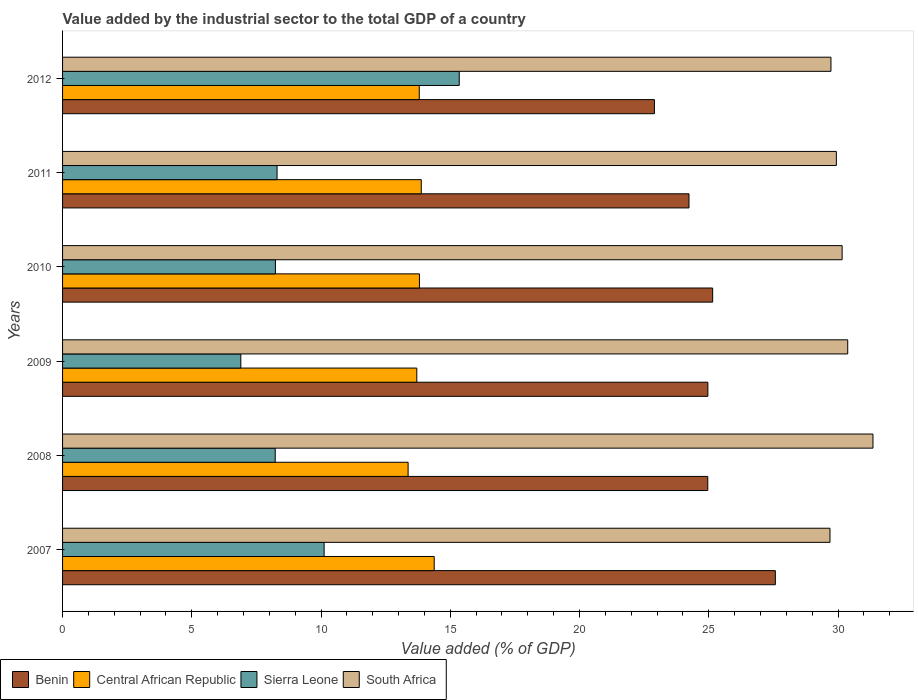How many groups of bars are there?
Make the answer very short. 6. Are the number of bars per tick equal to the number of legend labels?
Keep it short and to the point. Yes. Are the number of bars on each tick of the Y-axis equal?
Give a very brief answer. Yes. What is the label of the 4th group of bars from the top?
Provide a short and direct response. 2009. What is the value added by the industrial sector to the total GDP in Benin in 2007?
Provide a succinct answer. 27.58. Across all years, what is the maximum value added by the industrial sector to the total GDP in South Africa?
Offer a very short reply. 31.35. Across all years, what is the minimum value added by the industrial sector to the total GDP in Sierra Leone?
Your answer should be compact. 6.9. In which year was the value added by the industrial sector to the total GDP in South Africa maximum?
Provide a succinct answer. 2008. In which year was the value added by the industrial sector to the total GDP in Benin minimum?
Ensure brevity in your answer.  2012. What is the total value added by the industrial sector to the total GDP in Sierra Leone in the graph?
Your response must be concise. 57.12. What is the difference between the value added by the industrial sector to the total GDP in Central African Republic in 2007 and that in 2010?
Keep it short and to the point. 0.57. What is the difference between the value added by the industrial sector to the total GDP in Sierra Leone in 2010 and the value added by the industrial sector to the total GDP in Central African Republic in 2012?
Give a very brief answer. -5.57. What is the average value added by the industrial sector to the total GDP in Central African Republic per year?
Your answer should be very brief. 13.82. In the year 2007, what is the difference between the value added by the industrial sector to the total GDP in Benin and value added by the industrial sector to the total GDP in Sierra Leone?
Ensure brevity in your answer.  17.46. In how many years, is the value added by the industrial sector to the total GDP in Sierra Leone greater than 29 %?
Offer a terse response. 0. What is the ratio of the value added by the industrial sector to the total GDP in Benin in 2010 to that in 2011?
Give a very brief answer. 1.04. Is the difference between the value added by the industrial sector to the total GDP in Benin in 2007 and 2012 greater than the difference between the value added by the industrial sector to the total GDP in Sierra Leone in 2007 and 2012?
Provide a succinct answer. Yes. What is the difference between the highest and the second highest value added by the industrial sector to the total GDP in Benin?
Your response must be concise. 2.43. What is the difference between the highest and the lowest value added by the industrial sector to the total GDP in Sierra Leone?
Your answer should be compact. 8.45. Is it the case that in every year, the sum of the value added by the industrial sector to the total GDP in Benin and value added by the industrial sector to the total GDP in Central African Republic is greater than the sum of value added by the industrial sector to the total GDP in South Africa and value added by the industrial sector to the total GDP in Sierra Leone?
Provide a short and direct response. Yes. What does the 4th bar from the top in 2012 represents?
Your answer should be very brief. Benin. What does the 1st bar from the bottom in 2007 represents?
Your response must be concise. Benin. Is it the case that in every year, the sum of the value added by the industrial sector to the total GDP in Sierra Leone and value added by the industrial sector to the total GDP in Central African Republic is greater than the value added by the industrial sector to the total GDP in South Africa?
Provide a succinct answer. No. Are all the bars in the graph horizontal?
Keep it short and to the point. Yes. What is the difference between two consecutive major ticks on the X-axis?
Your answer should be compact. 5. Are the values on the major ticks of X-axis written in scientific E-notation?
Make the answer very short. No. How many legend labels are there?
Provide a short and direct response. 4. What is the title of the graph?
Your response must be concise. Value added by the industrial sector to the total GDP of a country. Does "China" appear as one of the legend labels in the graph?
Give a very brief answer. No. What is the label or title of the X-axis?
Offer a terse response. Value added (% of GDP). What is the Value added (% of GDP) in Benin in 2007?
Make the answer very short. 27.58. What is the Value added (% of GDP) in Central African Republic in 2007?
Offer a terse response. 14.38. What is the Value added (% of GDP) in Sierra Leone in 2007?
Your response must be concise. 10.12. What is the Value added (% of GDP) in South Africa in 2007?
Keep it short and to the point. 29.69. What is the Value added (% of GDP) in Benin in 2008?
Your response must be concise. 24.96. What is the Value added (% of GDP) of Central African Republic in 2008?
Offer a very short reply. 13.37. What is the Value added (% of GDP) in Sierra Leone in 2008?
Make the answer very short. 8.23. What is the Value added (% of GDP) of South Africa in 2008?
Provide a short and direct response. 31.35. What is the Value added (% of GDP) in Benin in 2009?
Ensure brevity in your answer.  24.97. What is the Value added (% of GDP) of Central African Republic in 2009?
Your response must be concise. 13.7. What is the Value added (% of GDP) of Sierra Leone in 2009?
Give a very brief answer. 6.9. What is the Value added (% of GDP) of South Africa in 2009?
Provide a succinct answer. 30.38. What is the Value added (% of GDP) in Benin in 2010?
Offer a very short reply. 25.15. What is the Value added (% of GDP) of Central African Republic in 2010?
Your answer should be very brief. 13.81. What is the Value added (% of GDP) in Sierra Leone in 2010?
Make the answer very short. 8.23. What is the Value added (% of GDP) in South Africa in 2010?
Provide a short and direct response. 30.16. What is the Value added (% of GDP) in Benin in 2011?
Your answer should be very brief. 24.24. What is the Value added (% of GDP) of Central African Republic in 2011?
Keep it short and to the point. 13.88. What is the Value added (% of GDP) of Sierra Leone in 2011?
Give a very brief answer. 8.3. What is the Value added (% of GDP) in South Africa in 2011?
Make the answer very short. 29.94. What is the Value added (% of GDP) in Benin in 2012?
Provide a short and direct response. 22.9. What is the Value added (% of GDP) in Central African Republic in 2012?
Your answer should be compact. 13.8. What is the Value added (% of GDP) of Sierra Leone in 2012?
Your answer should be very brief. 15.35. What is the Value added (% of GDP) of South Africa in 2012?
Your answer should be compact. 29.73. Across all years, what is the maximum Value added (% of GDP) in Benin?
Provide a short and direct response. 27.58. Across all years, what is the maximum Value added (% of GDP) of Central African Republic?
Provide a succinct answer. 14.38. Across all years, what is the maximum Value added (% of GDP) of Sierra Leone?
Your answer should be compact. 15.35. Across all years, what is the maximum Value added (% of GDP) in South Africa?
Give a very brief answer. 31.35. Across all years, what is the minimum Value added (% of GDP) in Benin?
Offer a terse response. 22.9. Across all years, what is the minimum Value added (% of GDP) in Central African Republic?
Offer a terse response. 13.37. Across all years, what is the minimum Value added (% of GDP) of Sierra Leone?
Your answer should be very brief. 6.9. Across all years, what is the minimum Value added (% of GDP) of South Africa?
Provide a succinct answer. 29.69. What is the total Value added (% of GDP) of Benin in the graph?
Offer a very short reply. 149.79. What is the total Value added (% of GDP) of Central African Republic in the graph?
Offer a terse response. 82.93. What is the total Value added (% of GDP) of Sierra Leone in the graph?
Keep it short and to the point. 57.12. What is the total Value added (% of GDP) of South Africa in the graph?
Offer a very short reply. 181.24. What is the difference between the Value added (% of GDP) in Benin in 2007 and that in 2008?
Provide a succinct answer. 2.61. What is the difference between the Value added (% of GDP) in Central African Republic in 2007 and that in 2008?
Keep it short and to the point. 1.01. What is the difference between the Value added (% of GDP) of Sierra Leone in 2007 and that in 2008?
Give a very brief answer. 1.89. What is the difference between the Value added (% of GDP) in South Africa in 2007 and that in 2008?
Your answer should be very brief. -1.66. What is the difference between the Value added (% of GDP) of Benin in 2007 and that in 2009?
Your response must be concise. 2.61. What is the difference between the Value added (% of GDP) of Central African Republic in 2007 and that in 2009?
Ensure brevity in your answer.  0.67. What is the difference between the Value added (% of GDP) of Sierra Leone in 2007 and that in 2009?
Offer a very short reply. 3.22. What is the difference between the Value added (% of GDP) in South Africa in 2007 and that in 2009?
Provide a succinct answer. -0.69. What is the difference between the Value added (% of GDP) of Benin in 2007 and that in 2010?
Your answer should be compact. 2.43. What is the difference between the Value added (% of GDP) in Central African Republic in 2007 and that in 2010?
Make the answer very short. 0.57. What is the difference between the Value added (% of GDP) of Sierra Leone in 2007 and that in 2010?
Your response must be concise. 1.88. What is the difference between the Value added (% of GDP) of South Africa in 2007 and that in 2010?
Ensure brevity in your answer.  -0.47. What is the difference between the Value added (% of GDP) of Benin in 2007 and that in 2011?
Offer a terse response. 3.34. What is the difference between the Value added (% of GDP) in Central African Republic in 2007 and that in 2011?
Ensure brevity in your answer.  0.5. What is the difference between the Value added (% of GDP) of Sierra Leone in 2007 and that in 2011?
Give a very brief answer. 1.82. What is the difference between the Value added (% of GDP) of South Africa in 2007 and that in 2011?
Your answer should be very brief. -0.25. What is the difference between the Value added (% of GDP) of Benin in 2007 and that in 2012?
Keep it short and to the point. 4.68. What is the difference between the Value added (% of GDP) of Central African Republic in 2007 and that in 2012?
Keep it short and to the point. 0.58. What is the difference between the Value added (% of GDP) of Sierra Leone in 2007 and that in 2012?
Ensure brevity in your answer.  -5.23. What is the difference between the Value added (% of GDP) of South Africa in 2007 and that in 2012?
Keep it short and to the point. -0.04. What is the difference between the Value added (% of GDP) in Benin in 2008 and that in 2009?
Your answer should be very brief. -0. What is the difference between the Value added (% of GDP) in Central African Republic in 2008 and that in 2009?
Your answer should be very brief. -0.34. What is the difference between the Value added (% of GDP) of Sierra Leone in 2008 and that in 2009?
Make the answer very short. 1.33. What is the difference between the Value added (% of GDP) of South Africa in 2008 and that in 2009?
Keep it short and to the point. 0.98. What is the difference between the Value added (% of GDP) of Benin in 2008 and that in 2010?
Provide a succinct answer. -0.19. What is the difference between the Value added (% of GDP) of Central African Republic in 2008 and that in 2010?
Provide a succinct answer. -0.44. What is the difference between the Value added (% of GDP) in Sierra Leone in 2008 and that in 2010?
Your response must be concise. -0.01. What is the difference between the Value added (% of GDP) in South Africa in 2008 and that in 2010?
Give a very brief answer. 1.19. What is the difference between the Value added (% of GDP) of Benin in 2008 and that in 2011?
Provide a short and direct response. 0.73. What is the difference between the Value added (% of GDP) in Central African Republic in 2008 and that in 2011?
Your answer should be very brief. -0.51. What is the difference between the Value added (% of GDP) in Sierra Leone in 2008 and that in 2011?
Make the answer very short. -0.07. What is the difference between the Value added (% of GDP) in South Africa in 2008 and that in 2011?
Your answer should be very brief. 1.42. What is the difference between the Value added (% of GDP) of Benin in 2008 and that in 2012?
Your response must be concise. 2.06. What is the difference between the Value added (% of GDP) in Central African Republic in 2008 and that in 2012?
Offer a terse response. -0.43. What is the difference between the Value added (% of GDP) of Sierra Leone in 2008 and that in 2012?
Give a very brief answer. -7.12. What is the difference between the Value added (% of GDP) in South Africa in 2008 and that in 2012?
Your response must be concise. 1.63. What is the difference between the Value added (% of GDP) of Benin in 2009 and that in 2010?
Offer a terse response. -0.19. What is the difference between the Value added (% of GDP) of Central African Republic in 2009 and that in 2010?
Your response must be concise. -0.1. What is the difference between the Value added (% of GDP) in Sierra Leone in 2009 and that in 2010?
Make the answer very short. -1.34. What is the difference between the Value added (% of GDP) of South Africa in 2009 and that in 2010?
Make the answer very short. 0.22. What is the difference between the Value added (% of GDP) in Benin in 2009 and that in 2011?
Your answer should be compact. 0.73. What is the difference between the Value added (% of GDP) of Central African Republic in 2009 and that in 2011?
Provide a short and direct response. -0.17. What is the difference between the Value added (% of GDP) in Sierra Leone in 2009 and that in 2011?
Give a very brief answer. -1.4. What is the difference between the Value added (% of GDP) of South Africa in 2009 and that in 2011?
Your response must be concise. 0.44. What is the difference between the Value added (% of GDP) of Benin in 2009 and that in 2012?
Offer a very short reply. 2.07. What is the difference between the Value added (% of GDP) in Central African Republic in 2009 and that in 2012?
Keep it short and to the point. -0.1. What is the difference between the Value added (% of GDP) of Sierra Leone in 2009 and that in 2012?
Provide a succinct answer. -8.45. What is the difference between the Value added (% of GDP) of South Africa in 2009 and that in 2012?
Ensure brevity in your answer.  0.65. What is the difference between the Value added (% of GDP) of Benin in 2010 and that in 2011?
Make the answer very short. 0.92. What is the difference between the Value added (% of GDP) of Central African Republic in 2010 and that in 2011?
Give a very brief answer. -0.07. What is the difference between the Value added (% of GDP) of Sierra Leone in 2010 and that in 2011?
Offer a terse response. -0.06. What is the difference between the Value added (% of GDP) in South Africa in 2010 and that in 2011?
Provide a short and direct response. 0.22. What is the difference between the Value added (% of GDP) of Benin in 2010 and that in 2012?
Your response must be concise. 2.25. What is the difference between the Value added (% of GDP) in Central African Republic in 2010 and that in 2012?
Provide a succinct answer. 0.01. What is the difference between the Value added (% of GDP) of Sierra Leone in 2010 and that in 2012?
Make the answer very short. -7.11. What is the difference between the Value added (% of GDP) in South Africa in 2010 and that in 2012?
Ensure brevity in your answer.  0.43. What is the difference between the Value added (% of GDP) in Benin in 2011 and that in 2012?
Your answer should be very brief. 1.34. What is the difference between the Value added (% of GDP) in Central African Republic in 2011 and that in 2012?
Provide a succinct answer. 0.08. What is the difference between the Value added (% of GDP) in Sierra Leone in 2011 and that in 2012?
Your response must be concise. -7.05. What is the difference between the Value added (% of GDP) of South Africa in 2011 and that in 2012?
Your answer should be compact. 0.21. What is the difference between the Value added (% of GDP) in Benin in 2007 and the Value added (% of GDP) in Central African Republic in 2008?
Make the answer very short. 14.21. What is the difference between the Value added (% of GDP) in Benin in 2007 and the Value added (% of GDP) in Sierra Leone in 2008?
Offer a terse response. 19.35. What is the difference between the Value added (% of GDP) in Benin in 2007 and the Value added (% of GDP) in South Africa in 2008?
Provide a short and direct response. -3.78. What is the difference between the Value added (% of GDP) in Central African Republic in 2007 and the Value added (% of GDP) in Sierra Leone in 2008?
Offer a terse response. 6.15. What is the difference between the Value added (% of GDP) in Central African Republic in 2007 and the Value added (% of GDP) in South Africa in 2008?
Your response must be concise. -16.97. What is the difference between the Value added (% of GDP) of Sierra Leone in 2007 and the Value added (% of GDP) of South Africa in 2008?
Make the answer very short. -21.23. What is the difference between the Value added (% of GDP) of Benin in 2007 and the Value added (% of GDP) of Central African Republic in 2009?
Provide a succinct answer. 13.87. What is the difference between the Value added (% of GDP) of Benin in 2007 and the Value added (% of GDP) of Sierra Leone in 2009?
Your response must be concise. 20.68. What is the difference between the Value added (% of GDP) in Benin in 2007 and the Value added (% of GDP) in South Africa in 2009?
Provide a short and direct response. -2.8. What is the difference between the Value added (% of GDP) in Central African Republic in 2007 and the Value added (% of GDP) in Sierra Leone in 2009?
Keep it short and to the point. 7.48. What is the difference between the Value added (% of GDP) of Central African Republic in 2007 and the Value added (% of GDP) of South Africa in 2009?
Provide a short and direct response. -16. What is the difference between the Value added (% of GDP) in Sierra Leone in 2007 and the Value added (% of GDP) in South Africa in 2009?
Offer a very short reply. -20.26. What is the difference between the Value added (% of GDP) in Benin in 2007 and the Value added (% of GDP) in Central African Republic in 2010?
Your response must be concise. 13.77. What is the difference between the Value added (% of GDP) in Benin in 2007 and the Value added (% of GDP) in Sierra Leone in 2010?
Provide a short and direct response. 19.34. What is the difference between the Value added (% of GDP) in Benin in 2007 and the Value added (% of GDP) in South Africa in 2010?
Offer a very short reply. -2.58. What is the difference between the Value added (% of GDP) of Central African Republic in 2007 and the Value added (% of GDP) of Sierra Leone in 2010?
Give a very brief answer. 6.14. What is the difference between the Value added (% of GDP) in Central African Republic in 2007 and the Value added (% of GDP) in South Africa in 2010?
Your response must be concise. -15.78. What is the difference between the Value added (% of GDP) in Sierra Leone in 2007 and the Value added (% of GDP) in South Africa in 2010?
Provide a short and direct response. -20.04. What is the difference between the Value added (% of GDP) of Benin in 2007 and the Value added (% of GDP) of Central African Republic in 2011?
Provide a short and direct response. 13.7. What is the difference between the Value added (% of GDP) of Benin in 2007 and the Value added (% of GDP) of Sierra Leone in 2011?
Provide a short and direct response. 19.28. What is the difference between the Value added (% of GDP) of Benin in 2007 and the Value added (% of GDP) of South Africa in 2011?
Ensure brevity in your answer.  -2.36. What is the difference between the Value added (% of GDP) in Central African Republic in 2007 and the Value added (% of GDP) in Sierra Leone in 2011?
Give a very brief answer. 6.08. What is the difference between the Value added (% of GDP) in Central African Republic in 2007 and the Value added (% of GDP) in South Africa in 2011?
Give a very brief answer. -15.56. What is the difference between the Value added (% of GDP) of Sierra Leone in 2007 and the Value added (% of GDP) of South Africa in 2011?
Offer a terse response. -19.82. What is the difference between the Value added (% of GDP) in Benin in 2007 and the Value added (% of GDP) in Central African Republic in 2012?
Your answer should be compact. 13.78. What is the difference between the Value added (% of GDP) in Benin in 2007 and the Value added (% of GDP) in Sierra Leone in 2012?
Provide a succinct answer. 12.23. What is the difference between the Value added (% of GDP) in Benin in 2007 and the Value added (% of GDP) in South Africa in 2012?
Your answer should be very brief. -2.15. What is the difference between the Value added (% of GDP) of Central African Republic in 2007 and the Value added (% of GDP) of Sierra Leone in 2012?
Your answer should be compact. -0.97. What is the difference between the Value added (% of GDP) in Central African Republic in 2007 and the Value added (% of GDP) in South Africa in 2012?
Provide a short and direct response. -15.35. What is the difference between the Value added (% of GDP) of Sierra Leone in 2007 and the Value added (% of GDP) of South Africa in 2012?
Ensure brevity in your answer.  -19.61. What is the difference between the Value added (% of GDP) of Benin in 2008 and the Value added (% of GDP) of Central African Republic in 2009?
Your answer should be very brief. 11.26. What is the difference between the Value added (% of GDP) in Benin in 2008 and the Value added (% of GDP) in Sierra Leone in 2009?
Give a very brief answer. 18.07. What is the difference between the Value added (% of GDP) in Benin in 2008 and the Value added (% of GDP) in South Africa in 2009?
Offer a terse response. -5.41. What is the difference between the Value added (% of GDP) of Central African Republic in 2008 and the Value added (% of GDP) of Sierra Leone in 2009?
Your answer should be very brief. 6.47. What is the difference between the Value added (% of GDP) of Central African Republic in 2008 and the Value added (% of GDP) of South Africa in 2009?
Provide a short and direct response. -17.01. What is the difference between the Value added (% of GDP) of Sierra Leone in 2008 and the Value added (% of GDP) of South Africa in 2009?
Give a very brief answer. -22.15. What is the difference between the Value added (% of GDP) of Benin in 2008 and the Value added (% of GDP) of Central African Republic in 2010?
Provide a succinct answer. 11.16. What is the difference between the Value added (% of GDP) of Benin in 2008 and the Value added (% of GDP) of Sierra Leone in 2010?
Keep it short and to the point. 16.73. What is the difference between the Value added (% of GDP) of Benin in 2008 and the Value added (% of GDP) of South Africa in 2010?
Give a very brief answer. -5.2. What is the difference between the Value added (% of GDP) in Central African Republic in 2008 and the Value added (% of GDP) in Sierra Leone in 2010?
Provide a succinct answer. 5.13. What is the difference between the Value added (% of GDP) of Central African Republic in 2008 and the Value added (% of GDP) of South Africa in 2010?
Your answer should be very brief. -16.79. What is the difference between the Value added (% of GDP) of Sierra Leone in 2008 and the Value added (% of GDP) of South Africa in 2010?
Offer a very short reply. -21.93. What is the difference between the Value added (% of GDP) in Benin in 2008 and the Value added (% of GDP) in Central African Republic in 2011?
Keep it short and to the point. 11.08. What is the difference between the Value added (% of GDP) in Benin in 2008 and the Value added (% of GDP) in Sierra Leone in 2011?
Make the answer very short. 16.66. What is the difference between the Value added (% of GDP) of Benin in 2008 and the Value added (% of GDP) of South Africa in 2011?
Keep it short and to the point. -4.97. What is the difference between the Value added (% of GDP) in Central African Republic in 2008 and the Value added (% of GDP) in Sierra Leone in 2011?
Your response must be concise. 5.07. What is the difference between the Value added (% of GDP) of Central African Republic in 2008 and the Value added (% of GDP) of South Africa in 2011?
Your response must be concise. -16.57. What is the difference between the Value added (% of GDP) of Sierra Leone in 2008 and the Value added (% of GDP) of South Africa in 2011?
Your response must be concise. -21.71. What is the difference between the Value added (% of GDP) in Benin in 2008 and the Value added (% of GDP) in Central African Republic in 2012?
Offer a terse response. 11.16. What is the difference between the Value added (% of GDP) of Benin in 2008 and the Value added (% of GDP) of Sierra Leone in 2012?
Offer a terse response. 9.61. What is the difference between the Value added (% of GDP) of Benin in 2008 and the Value added (% of GDP) of South Africa in 2012?
Your answer should be very brief. -4.77. What is the difference between the Value added (% of GDP) in Central African Republic in 2008 and the Value added (% of GDP) in Sierra Leone in 2012?
Make the answer very short. -1.98. What is the difference between the Value added (% of GDP) in Central African Republic in 2008 and the Value added (% of GDP) in South Africa in 2012?
Your response must be concise. -16.36. What is the difference between the Value added (% of GDP) of Sierra Leone in 2008 and the Value added (% of GDP) of South Africa in 2012?
Keep it short and to the point. -21.5. What is the difference between the Value added (% of GDP) in Benin in 2009 and the Value added (% of GDP) in Central African Republic in 2010?
Make the answer very short. 11.16. What is the difference between the Value added (% of GDP) of Benin in 2009 and the Value added (% of GDP) of Sierra Leone in 2010?
Your answer should be compact. 16.73. What is the difference between the Value added (% of GDP) in Benin in 2009 and the Value added (% of GDP) in South Africa in 2010?
Give a very brief answer. -5.19. What is the difference between the Value added (% of GDP) in Central African Republic in 2009 and the Value added (% of GDP) in Sierra Leone in 2010?
Offer a very short reply. 5.47. What is the difference between the Value added (% of GDP) of Central African Republic in 2009 and the Value added (% of GDP) of South Africa in 2010?
Provide a short and direct response. -16.46. What is the difference between the Value added (% of GDP) in Sierra Leone in 2009 and the Value added (% of GDP) in South Africa in 2010?
Provide a short and direct response. -23.26. What is the difference between the Value added (% of GDP) of Benin in 2009 and the Value added (% of GDP) of Central African Republic in 2011?
Keep it short and to the point. 11.09. What is the difference between the Value added (% of GDP) in Benin in 2009 and the Value added (% of GDP) in Sierra Leone in 2011?
Keep it short and to the point. 16.67. What is the difference between the Value added (% of GDP) of Benin in 2009 and the Value added (% of GDP) of South Africa in 2011?
Your answer should be very brief. -4.97. What is the difference between the Value added (% of GDP) in Central African Republic in 2009 and the Value added (% of GDP) in Sierra Leone in 2011?
Your response must be concise. 5.41. What is the difference between the Value added (% of GDP) in Central African Republic in 2009 and the Value added (% of GDP) in South Africa in 2011?
Keep it short and to the point. -16.23. What is the difference between the Value added (% of GDP) in Sierra Leone in 2009 and the Value added (% of GDP) in South Africa in 2011?
Make the answer very short. -23.04. What is the difference between the Value added (% of GDP) in Benin in 2009 and the Value added (% of GDP) in Central African Republic in 2012?
Make the answer very short. 11.17. What is the difference between the Value added (% of GDP) of Benin in 2009 and the Value added (% of GDP) of Sierra Leone in 2012?
Give a very brief answer. 9.62. What is the difference between the Value added (% of GDP) of Benin in 2009 and the Value added (% of GDP) of South Africa in 2012?
Provide a succinct answer. -4.76. What is the difference between the Value added (% of GDP) of Central African Republic in 2009 and the Value added (% of GDP) of Sierra Leone in 2012?
Your answer should be compact. -1.64. What is the difference between the Value added (% of GDP) of Central African Republic in 2009 and the Value added (% of GDP) of South Africa in 2012?
Provide a short and direct response. -16.02. What is the difference between the Value added (% of GDP) of Sierra Leone in 2009 and the Value added (% of GDP) of South Africa in 2012?
Provide a succinct answer. -22.83. What is the difference between the Value added (% of GDP) in Benin in 2010 and the Value added (% of GDP) in Central African Republic in 2011?
Offer a terse response. 11.27. What is the difference between the Value added (% of GDP) in Benin in 2010 and the Value added (% of GDP) in Sierra Leone in 2011?
Keep it short and to the point. 16.85. What is the difference between the Value added (% of GDP) in Benin in 2010 and the Value added (% of GDP) in South Africa in 2011?
Provide a succinct answer. -4.79. What is the difference between the Value added (% of GDP) of Central African Republic in 2010 and the Value added (% of GDP) of Sierra Leone in 2011?
Offer a very short reply. 5.51. What is the difference between the Value added (% of GDP) in Central African Republic in 2010 and the Value added (% of GDP) in South Africa in 2011?
Offer a terse response. -16.13. What is the difference between the Value added (% of GDP) of Sierra Leone in 2010 and the Value added (% of GDP) of South Africa in 2011?
Make the answer very short. -21.7. What is the difference between the Value added (% of GDP) of Benin in 2010 and the Value added (% of GDP) of Central African Republic in 2012?
Your response must be concise. 11.35. What is the difference between the Value added (% of GDP) in Benin in 2010 and the Value added (% of GDP) in Sierra Leone in 2012?
Provide a succinct answer. 9.8. What is the difference between the Value added (% of GDP) in Benin in 2010 and the Value added (% of GDP) in South Africa in 2012?
Keep it short and to the point. -4.58. What is the difference between the Value added (% of GDP) in Central African Republic in 2010 and the Value added (% of GDP) in Sierra Leone in 2012?
Keep it short and to the point. -1.54. What is the difference between the Value added (% of GDP) of Central African Republic in 2010 and the Value added (% of GDP) of South Africa in 2012?
Make the answer very short. -15.92. What is the difference between the Value added (% of GDP) of Sierra Leone in 2010 and the Value added (% of GDP) of South Africa in 2012?
Ensure brevity in your answer.  -21.49. What is the difference between the Value added (% of GDP) of Benin in 2011 and the Value added (% of GDP) of Central African Republic in 2012?
Provide a succinct answer. 10.44. What is the difference between the Value added (% of GDP) of Benin in 2011 and the Value added (% of GDP) of Sierra Leone in 2012?
Provide a short and direct response. 8.89. What is the difference between the Value added (% of GDP) in Benin in 2011 and the Value added (% of GDP) in South Africa in 2012?
Your answer should be compact. -5.49. What is the difference between the Value added (% of GDP) in Central African Republic in 2011 and the Value added (% of GDP) in Sierra Leone in 2012?
Offer a terse response. -1.47. What is the difference between the Value added (% of GDP) in Central African Republic in 2011 and the Value added (% of GDP) in South Africa in 2012?
Ensure brevity in your answer.  -15.85. What is the difference between the Value added (% of GDP) of Sierra Leone in 2011 and the Value added (% of GDP) of South Africa in 2012?
Your response must be concise. -21.43. What is the average Value added (% of GDP) of Benin per year?
Your answer should be very brief. 24.96. What is the average Value added (% of GDP) in Central African Republic per year?
Keep it short and to the point. 13.82. What is the average Value added (% of GDP) of Sierra Leone per year?
Offer a very short reply. 9.52. What is the average Value added (% of GDP) in South Africa per year?
Offer a very short reply. 30.21. In the year 2007, what is the difference between the Value added (% of GDP) of Benin and Value added (% of GDP) of Central African Republic?
Provide a short and direct response. 13.2. In the year 2007, what is the difference between the Value added (% of GDP) of Benin and Value added (% of GDP) of Sierra Leone?
Your answer should be compact. 17.46. In the year 2007, what is the difference between the Value added (% of GDP) of Benin and Value added (% of GDP) of South Africa?
Offer a very short reply. -2.11. In the year 2007, what is the difference between the Value added (% of GDP) in Central African Republic and Value added (% of GDP) in Sierra Leone?
Provide a succinct answer. 4.26. In the year 2007, what is the difference between the Value added (% of GDP) of Central African Republic and Value added (% of GDP) of South Africa?
Your answer should be compact. -15.31. In the year 2007, what is the difference between the Value added (% of GDP) in Sierra Leone and Value added (% of GDP) in South Africa?
Provide a short and direct response. -19.57. In the year 2008, what is the difference between the Value added (% of GDP) in Benin and Value added (% of GDP) in Central African Republic?
Ensure brevity in your answer.  11.59. In the year 2008, what is the difference between the Value added (% of GDP) in Benin and Value added (% of GDP) in Sierra Leone?
Your answer should be compact. 16.73. In the year 2008, what is the difference between the Value added (% of GDP) in Benin and Value added (% of GDP) in South Africa?
Provide a short and direct response. -6.39. In the year 2008, what is the difference between the Value added (% of GDP) of Central African Republic and Value added (% of GDP) of Sierra Leone?
Offer a very short reply. 5.14. In the year 2008, what is the difference between the Value added (% of GDP) in Central African Republic and Value added (% of GDP) in South Africa?
Make the answer very short. -17.98. In the year 2008, what is the difference between the Value added (% of GDP) of Sierra Leone and Value added (% of GDP) of South Africa?
Offer a very short reply. -23.13. In the year 2009, what is the difference between the Value added (% of GDP) in Benin and Value added (% of GDP) in Central African Republic?
Give a very brief answer. 11.26. In the year 2009, what is the difference between the Value added (% of GDP) of Benin and Value added (% of GDP) of Sierra Leone?
Provide a succinct answer. 18.07. In the year 2009, what is the difference between the Value added (% of GDP) in Benin and Value added (% of GDP) in South Africa?
Keep it short and to the point. -5.41. In the year 2009, what is the difference between the Value added (% of GDP) of Central African Republic and Value added (% of GDP) of Sierra Leone?
Provide a short and direct response. 6.81. In the year 2009, what is the difference between the Value added (% of GDP) in Central African Republic and Value added (% of GDP) in South Africa?
Provide a short and direct response. -16.67. In the year 2009, what is the difference between the Value added (% of GDP) of Sierra Leone and Value added (% of GDP) of South Africa?
Offer a very short reply. -23.48. In the year 2010, what is the difference between the Value added (% of GDP) of Benin and Value added (% of GDP) of Central African Republic?
Give a very brief answer. 11.34. In the year 2010, what is the difference between the Value added (% of GDP) in Benin and Value added (% of GDP) in Sierra Leone?
Your answer should be compact. 16.92. In the year 2010, what is the difference between the Value added (% of GDP) in Benin and Value added (% of GDP) in South Africa?
Your answer should be compact. -5.01. In the year 2010, what is the difference between the Value added (% of GDP) of Central African Republic and Value added (% of GDP) of Sierra Leone?
Your answer should be very brief. 5.57. In the year 2010, what is the difference between the Value added (% of GDP) in Central African Republic and Value added (% of GDP) in South Africa?
Your answer should be compact. -16.35. In the year 2010, what is the difference between the Value added (% of GDP) of Sierra Leone and Value added (% of GDP) of South Africa?
Your response must be concise. -21.93. In the year 2011, what is the difference between the Value added (% of GDP) in Benin and Value added (% of GDP) in Central African Republic?
Offer a very short reply. 10.36. In the year 2011, what is the difference between the Value added (% of GDP) in Benin and Value added (% of GDP) in Sierra Leone?
Provide a short and direct response. 15.94. In the year 2011, what is the difference between the Value added (% of GDP) in Benin and Value added (% of GDP) in South Africa?
Your response must be concise. -5.7. In the year 2011, what is the difference between the Value added (% of GDP) in Central African Republic and Value added (% of GDP) in Sierra Leone?
Ensure brevity in your answer.  5.58. In the year 2011, what is the difference between the Value added (% of GDP) of Central African Republic and Value added (% of GDP) of South Africa?
Give a very brief answer. -16.06. In the year 2011, what is the difference between the Value added (% of GDP) of Sierra Leone and Value added (% of GDP) of South Africa?
Ensure brevity in your answer.  -21.64. In the year 2012, what is the difference between the Value added (% of GDP) in Benin and Value added (% of GDP) in Central African Republic?
Provide a succinct answer. 9.1. In the year 2012, what is the difference between the Value added (% of GDP) of Benin and Value added (% of GDP) of Sierra Leone?
Offer a terse response. 7.55. In the year 2012, what is the difference between the Value added (% of GDP) of Benin and Value added (% of GDP) of South Africa?
Your answer should be very brief. -6.83. In the year 2012, what is the difference between the Value added (% of GDP) in Central African Republic and Value added (% of GDP) in Sierra Leone?
Offer a very short reply. -1.55. In the year 2012, what is the difference between the Value added (% of GDP) of Central African Republic and Value added (% of GDP) of South Africa?
Ensure brevity in your answer.  -15.93. In the year 2012, what is the difference between the Value added (% of GDP) in Sierra Leone and Value added (% of GDP) in South Africa?
Ensure brevity in your answer.  -14.38. What is the ratio of the Value added (% of GDP) in Benin in 2007 to that in 2008?
Offer a very short reply. 1.1. What is the ratio of the Value added (% of GDP) in Central African Republic in 2007 to that in 2008?
Keep it short and to the point. 1.08. What is the ratio of the Value added (% of GDP) of Sierra Leone in 2007 to that in 2008?
Provide a succinct answer. 1.23. What is the ratio of the Value added (% of GDP) in South Africa in 2007 to that in 2008?
Provide a succinct answer. 0.95. What is the ratio of the Value added (% of GDP) in Benin in 2007 to that in 2009?
Ensure brevity in your answer.  1.1. What is the ratio of the Value added (% of GDP) of Central African Republic in 2007 to that in 2009?
Your answer should be compact. 1.05. What is the ratio of the Value added (% of GDP) of Sierra Leone in 2007 to that in 2009?
Keep it short and to the point. 1.47. What is the ratio of the Value added (% of GDP) of South Africa in 2007 to that in 2009?
Ensure brevity in your answer.  0.98. What is the ratio of the Value added (% of GDP) of Benin in 2007 to that in 2010?
Provide a short and direct response. 1.1. What is the ratio of the Value added (% of GDP) of Central African Republic in 2007 to that in 2010?
Your response must be concise. 1.04. What is the ratio of the Value added (% of GDP) of Sierra Leone in 2007 to that in 2010?
Your response must be concise. 1.23. What is the ratio of the Value added (% of GDP) in South Africa in 2007 to that in 2010?
Offer a terse response. 0.98. What is the ratio of the Value added (% of GDP) of Benin in 2007 to that in 2011?
Give a very brief answer. 1.14. What is the ratio of the Value added (% of GDP) in Central African Republic in 2007 to that in 2011?
Make the answer very short. 1.04. What is the ratio of the Value added (% of GDP) in Sierra Leone in 2007 to that in 2011?
Keep it short and to the point. 1.22. What is the ratio of the Value added (% of GDP) in Benin in 2007 to that in 2012?
Offer a very short reply. 1.2. What is the ratio of the Value added (% of GDP) of Central African Republic in 2007 to that in 2012?
Keep it short and to the point. 1.04. What is the ratio of the Value added (% of GDP) in Sierra Leone in 2007 to that in 2012?
Your response must be concise. 0.66. What is the ratio of the Value added (% of GDP) in Benin in 2008 to that in 2009?
Your response must be concise. 1. What is the ratio of the Value added (% of GDP) of Central African Republic in 2008 to that in 2009?
Your response must be concise. 0.98. What is the ratio of the Value added (% of GDP) in Sierra Leone in 2008 to that in 2009?
Provide a succinct answer. 1.19. What is the ratio of the Value added (% of GDP) in South Africa in 2008 to that in 2009?
Offer a very short reply. 1.03. What is the ratio of the Value added (% of GDP) in Benin in 2008 to that in 2010?
Provide a short and direct response. 0.99. What is the ratio of the Value added (% of GDP) of Central African Republic in 2008 to that in 2010?
Provide a short and direct response. 0.97. What is the ratio of the Value added (% of GDP) of South Africa in 2008 to that in 2010?
Offer a very short reply. 1.04. What is the ratio of the Value added (% of GDP) of Benin in 2008 to that in 2011?
Make the answer very short. 1.03. What is the ratio of the Value added (% of GDP) of Central African Republic in 2008 to that in 2011?
Ensure brevity in your answer.  0.96. What is the ratio of the Value added (% of GDP) in South Africa in 2008 to that in 2011?
Offer a terse response. 1.05. What is the ratio of the Value added (% of GDP) in Benin in 2008 to that in 2012?
Offer a terse response. 1.09. What is the ratio of the Value added (% of GDP) of Central African Republic in 2008 to that in 2012?
Ensure brevity in your answer.  0.97. What is the ratio of the Value added (% of GDP) of Sierra Leone in 2008 to that in 2012?
Keep it short and to the point. 0.54. What is the ratio of the Value added (% of GDP) of South Africa in 2008 to that in 2012?
Your answer should be very brief. 1.05. What is the ratio of the Value added (% of GDP) in Sierra Leone in 2009 to that in 2010?
Provide a short and direct response. 0.84. What is the ratio of the Value added (% of GDP) in South Africa in 2009 to that in 2010?
Offer a terse response. 1.01. What is the ratio of the Value added (% of GDP) in Benin in 2009 to that in 2011?
Provide a short and direct response. 1.03. What is the ratio of the Value added (% of GDP) of Central African Republic in 2009 to that in 2011?
Offer a terse response. 0.99. What is the ratio of the Value added (% of GDP) of Sierra Leone in 2009 to that in 2011?
Make the answer very short. 0.83. What is the ratio of the Value added (% of GDP) in South Africa in 2009 to that in 2011?
Provide a short and direct response. 1.01. What is the ratio of the Value added (% of GDP) in Benin in 2009 to that in 2012?
Ensure brevity in your answer.  1.09. What is the ratio of the Value added (% of GDP) of Sierra Leone in 2009 to that in 2012?
Ensure brevity in your answer.  0.45. What is the ratio of the Value added (% of GDP) of South Africa in 2009 to that in 2012?
Keep it short and to the point. 1.02. What is the ratio of the Value added (% of GDP) in Benin in 2010 to that in 2011?
Make the answer very short. 1.04. What is the ratio of the Value added (% of GDP) in Central African Republic in 2010 to that in 2011?
Your answer should be compact. 0.99. What is the ratio of the Value added (% of GDP) of Sierra Leone in 2010 to that in 2011?
Your response must be concise. 0.99. What is the ratio of the Value added (% of GDP) in South Africa in 2010 to that in 2011?
Your answer should be compact. 1.01. What is the ratio of the Value added (% of GDP) in Benin in 2010 to that in 2012?
Provide a succinct answer. 1.1. What is the ratio of the Value added (% of GDP) in Sierra Leone in 2010 to that in 2012?
Provide a short and direct response. 0.54. What is the ratio of the Value added (% of GDP) of South Africa in 2010 to that in 2012?
Give a very brief answer. 1.01. What is the ratio of the Value added (% of GDP) in Benin in 2011 to that in 2012?
Your answer should be very brief. 1.06. What is the ratio of the Value added (% of GDP) in Central African Republic in 2011 to that in 2012?
Give a very brief answer. 1.01. What is the ratio of the Value added (% of GDP) in Sierra Leone in 2011 to that in 2012?
Offer a terse response. 0.54. What is the difference between the highest and the second highest Value added (% of GDP) of Benin?
Provide a short and direct response. 2.43. What is the difference between the highest and the second highest Value added (% of GDP) in Central African Republic?
Provide a short and direct response. 0.5. What is the difference between the highest and the second highest Value added (% of GDP) in Sierra Leone?
Offer a terse response. 5.23. What is the difference between the highest and the second highest Value added (% of GDP) in South Africa?
Keep it short and to the point. 0.98. What is the difference between the highest and the lowest Value added (% of GDP) of Benin?
Your response must be concise. 4.68. What is the difference between the highest and the lowest Value added (% of GDP) of Central African Republic?
Ensure brevity in your answer.  1.01. What is the difference between the highest and the lowest Value added (% of GDP) of Sierra Leone?
Give a very brief answer. 8.45. What is the difference between the highest and the lowest Value added (% of GDP) in South Africa?
Keep it short and to the point. 1.66. 